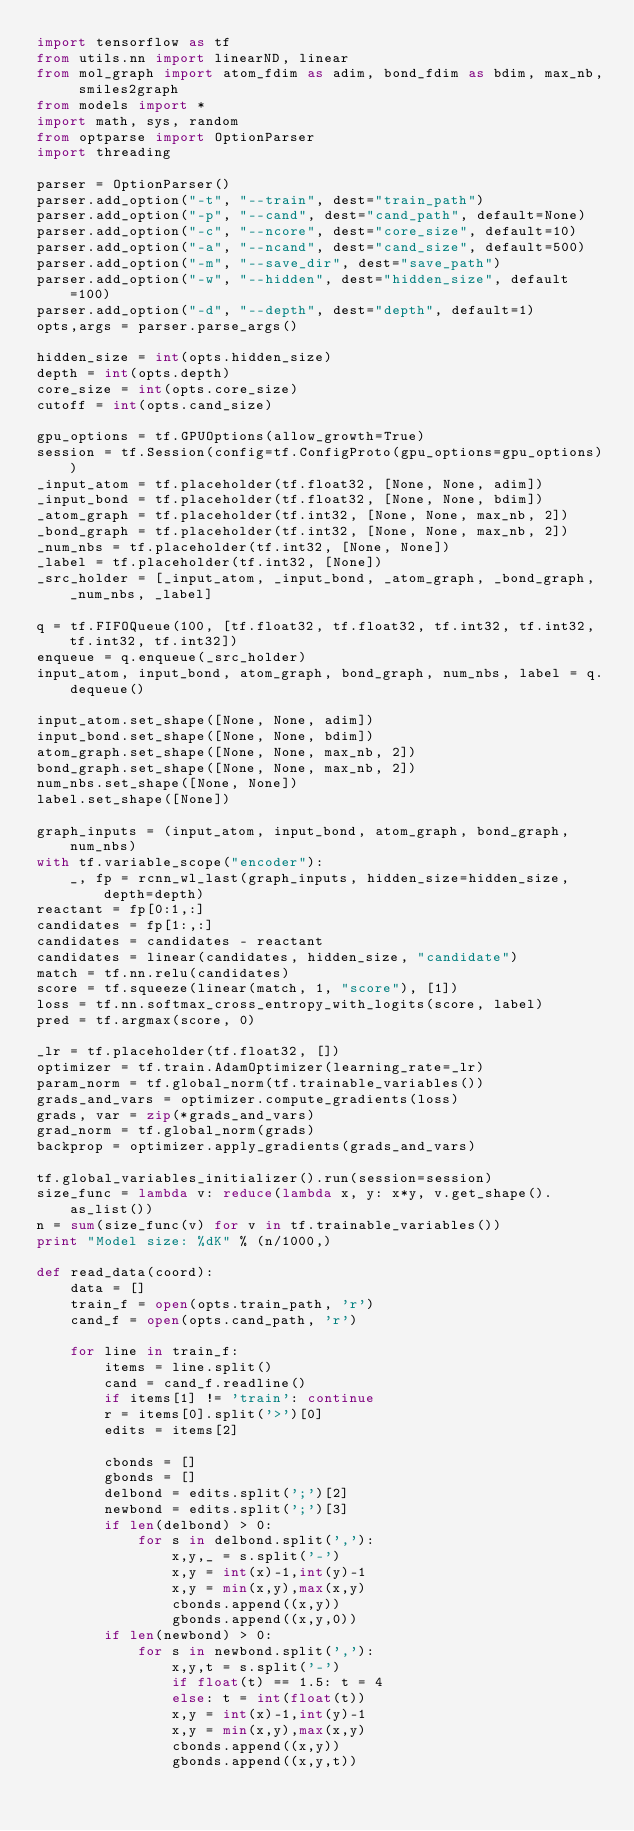Convert code to text. <code><loc_0><loc_0><loc_500><loc_500><_Python_>import tensorflow as tf
from utils.nn import linearND, linear
from mol_graph import atom_fdim as adim, bond_fdim as bdim, max_nb, smiles2graph
from models import *
import math, sys, random
from optparse import OptionParser
import threading

parser = OptionParser()
parser.add_option("-t", "--train", dest="train_path")
parser.add_option("-p", "--cand", dest="cand_path", default=None)
parser.add_option("-c", "--ncore", dest="core_size", default=10)
parser.add_option("-a", "--ncand", dest="cand_size", default=500)
parser.add_option("-m", "--save_dir", dest="save_path")
parser.add_option("-w", "--hidden", dest="hidden_size", default=100)
parser.add_option("-d", "--depth", dest="depth", default=1)
opts,args = parser.parse_args()

hidden_size = int(opts.hidden_size)
depth = int(opts.depth)
core_size = int(opts.core_size)
cutoff = int(opts.cand_size)

gpu_options = tf.GPUOptions(allow_growth=True)
session = tf.Session(config=tf.ConfigProto(gpu_options=gpu_options))
_input_atom = tf.placeholder(tf.float32, [None, None, adim])
_input_bond = tf.placeholder(tf.float32, [None, None, bdim])
_atom_graph = tf.placeholder(tf.int32, [None, None, max_nb, 2])
_bond_graph = tf.placeholder(tf.int32, [None, None, max_nb, 2])
_num_nbs = tf.placeholder(tf.int32, [None, None])
_label = tf.placeholder(tf.int32, [None])
_src_holder = [_input_atom, _input_bond, _atom_graph, _bond_graph, _num_nbs, _label]

q = tf.FIFOQueue(100, [tf.float32, tf.float32, tf.int32, tf.int32, tf.int32, tf.int32])
enqueue = q.enqueue(_src_holder)
input_atom, input_bond, atom_graph, bond_graph, num_nbs, label = q.dequeue()

input_atom.set_shape([None, None, adim])
input_bond.set_shape([None, None, bdim])
atom_graph.set_shape([None, None, max_nb, 2])
bond_graph.set_shape([None, None, max_nb, 2])
num_nbs.set_shape([None, None])
label.set_shape([None])

graph_inputs = (input_atom, input_bond, atom_graph, bond_graph, num_nbs) 
with tf.variable_scope("encoder"):
    _, fp = rcnn_wl_last(graph_inputs, hidden_size=hidden_size, depth=depth)
reactant = fp[0:1,:]
candidates = fp[1:,:]
candidates = candidates - reactant
candidates = linear(candidates, hidden_size, "candidate")
match = tf.nn.relu(candidates)
score = tf.squeeze(linear(match, 1, "score"), [1])
loss = tf.nn.softmax_cross_entropy_with_logits(score, label)
pred = tf.argmax(score, 0)

_lr = tf.placeholder(tf.float32, [])
optimizer = tf.train.AdamOptimizer(learning_rate=_lr)
param_norm = tf.global_norm(tf.trainable_variables())
grads_and_vars = optimizer.compute_gradients(loss) 
grads, var = zip(*grads_and_vars)
grad_norm = tf.global_norm(grads)
backprop = optimizer.apply_gradients(grads_and_vars)

tf.global_variables_initializer().run(session=session)
size_func = lambda v: reduce(lambda x, y: x*y, v.get_shape().as_list())
n = sum(size_func(v) for v in tf.trainable_variables())
print "Model size: %dK" % (n/1000,)

def read_data(coord):
    data = []
    train_f = open(opts.train_path, 'r')
    cand_f = open(opts.cand_path, 'r')
        
    for line in train_f:
        items = line.split()
        cand = cand_f.readline()
        if items[1] != 'train': continue
        r = items[0].split('>')[0]
        edits = items[2]

        cbonds = []
        gbonds = []
        delbond = edits.split(';')[2]
        newbond = edits.split(';')[3]
        if len(delbond) > 0:
            for s in delbond.split(','):
                x,y,_ = s.split('-')
                x,y = int(x)-1,int(y)-1
                x,y = min(x,y),max(x,y)
                cbonds.append((x,y))
                gbonds.append((x,y,0))
        if len(newbond) > 0:
            for s in newbond.split(','):
                x,y,t = s.split('-')
                if float(t) == 1.5: t = 4
                else: t = int(float(t))
                x,y = int(x)-1,int(y)-1
                x,y = min(x,y),max(x,y)
                cbonds.append((x,y))
                gbonds.append((x,y,t))
</code> 